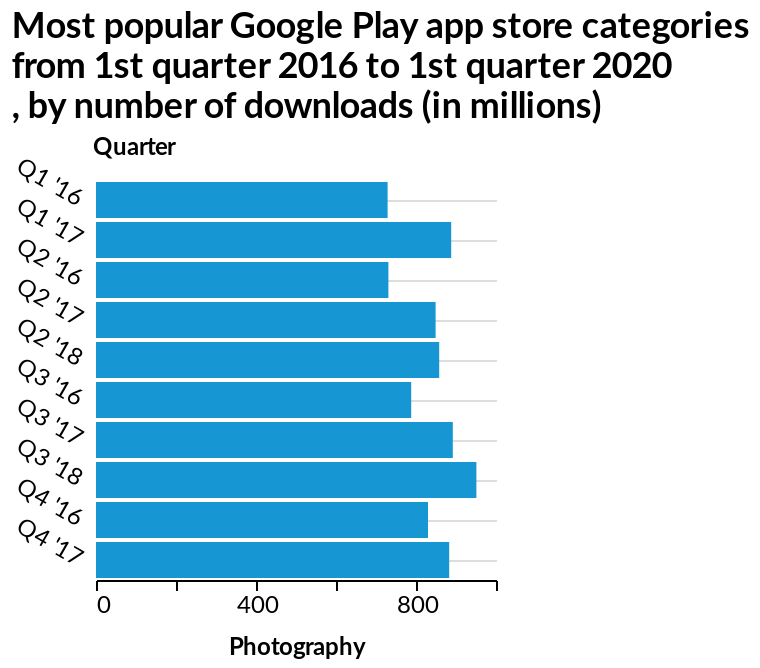<image>
Which category had the highest number of downloads? Photography had the highest number of downloads. 